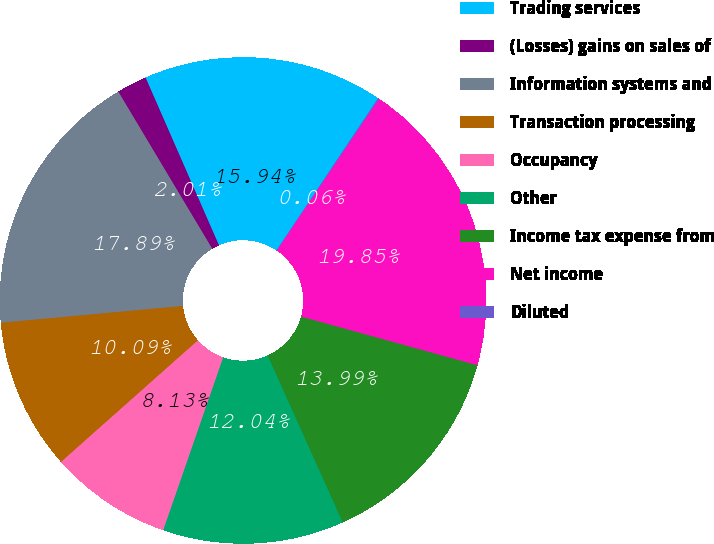<chart> <loc_0><loc_0><loc_500><loc_500><pie_chart><fcel>Trading services<fcel>(Losses) gains on sales of<fcel>Information systems and<fcel>Transaction processing<fcel>Occupancy<fcel>Other<fcel>Income tax expense from<fcel>Net income<fcel>Diluted<nl><fcel>15.94%<fcel>2.01%<fcel>17.89%<fcel>10.09%<fcel>8.13%<fcel>12.04%<fcel>13.99%<fcel>19.85%<fcel>0.06%<nl></chart> 